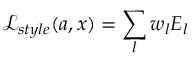<formula> <loc_0><loc_0><loc_500><loc_500>\mathcal { L } _ { s t y l e } ( a , x ) = \sum _ { l } w _ { l } E _ { l }</formula> 